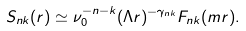Convert formula to latex. <formula><loc_0><loc_0><loc_500><loc_500>S _ { n k } ( r ) \simeq \nu _ { 0 } ^ { - n - k } ( \Lambda r ) ^ { - \gamma _ { n k } } F _ { n k } ( m r ) .</formula> 